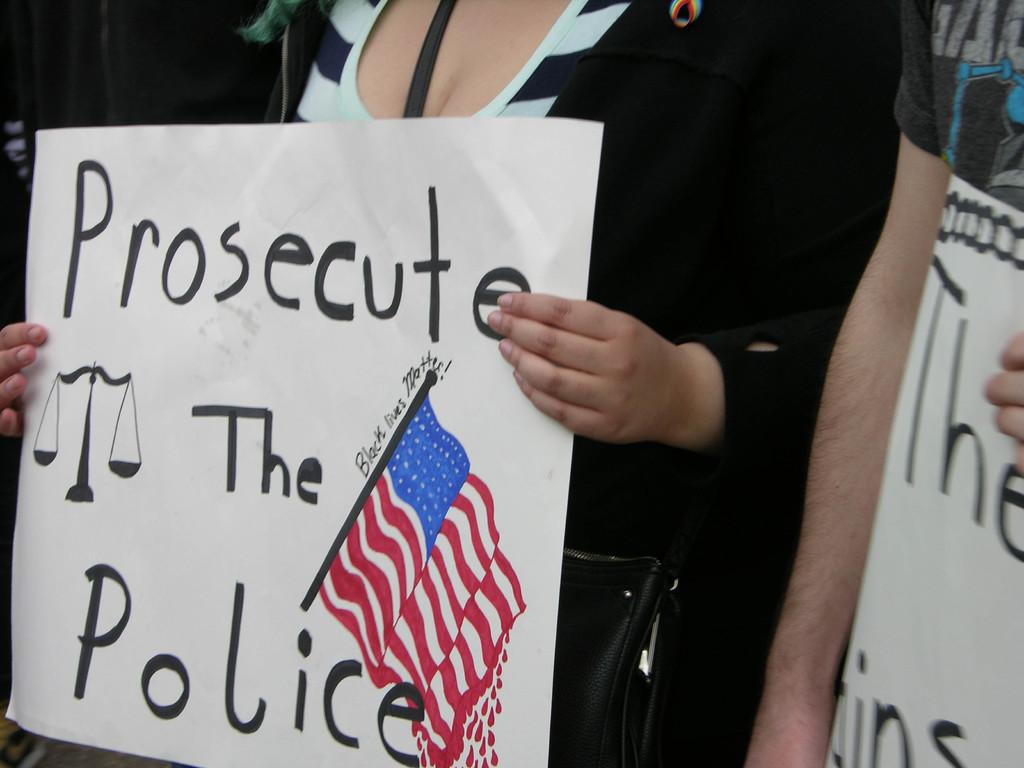<image>
Present a compact description of the photo's key features. Protester holding a sign saying Prosecute the Police with the American flag on it. 